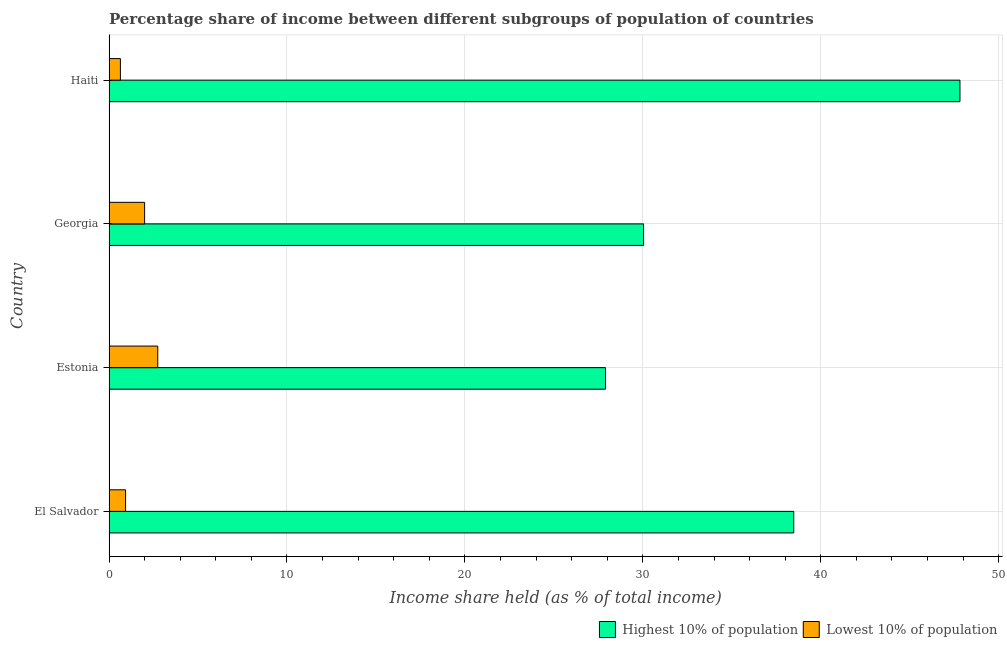How many different coloured bars are there?
Keep it short and to the point. 2. How many groups of bars are there?
Provide a succinct answer. 4. Are the number of bars per tick equal to the number of legend labels?
Provide a short and direct response. Yes. Are the number of bars on each tick of the Y-axis equal?
Offer a terse response. Yes. How many bars are there on the 3rd tick from the bottom?
Your answer should be compact. 2. What is the label of the 3rd group of bars from the top?
Keep it short and to the point. Estonia. What is the income share held by highest 10% of the population in Georgia?
Provide a short and direct response. 30.04. Across all countries, what is the maximum income share held by highest 10% of the population?
Your answer should be compact. 47.82. Across all countries, what is the minimum income share held by highest 10% of the population?
Ensure brevity in your answer.  27.9. In which country was the income share held by highest 10% of the population maximum?
Offer a terse response. Haiti. In which country was the income share held by highest 10% of the population minimum?
Give a very brief answer. Estonia. What is the total income share held by lowest 10% of the population in the graph?
Ensure brevity in your answer.  6.31. What is the difference between the income share held by highest 10% of the population in El Salvador and that in Haiti?
Offer a terse response. -9.34. What is the difference between the income share held by highest 10% of the population in Estonia and the income share held by lowest 10% of the population in Georgia?
Provide a succinct answer. 25.9. What is the average income share held by highest 10% of the population per country?
Provide a short and direct response. 36.06. What is the difference between the income share held by highest 10% of the population and income share held by lowest 10% of the population in El Salvador?
Keep it short and to the point. 37.55. In how many countries, is the income share held by highest 10% of the population greater than 44 %?
Ensure brevity in your answer.  1. What is the ratio of the income share held by highest 10% of the population in El Salvador to that in Estonia?
Make the answer very short. 1.38. Is the difference between the income share held by highest 10% of the population in Georgia and Haiti greater than the difference between the income share held by lowest 10% of the population in Georgia and Haiti?
Your answer should be compact. No. What is the difference between the highest and the second highest income share held by highest 10% of the population?
Offer a very short reply. 9.34. Is the sum of the income share held by highest 10% of the population in El Salvador and Estonia greater than the maximum income share held by lowest 10% of the population across all countries?
Provide a succinct answer. Yes. What does the 2nd bar from the top in Georgia represents?
Provide a short and direct response. Highest 10% of population. What does the 2nd bar from the bottom in Georgia represents?
Give a very brief answer. Lowest 10% of population. Does the graph contain any zero values?
Offer a terse response. No. Where does the legend appear in the graph?
Your answer should be compact. Bottom right. What is the title of the graph?
Keep it short and to the point. Percentage share of income between different subgroups of population of countries. Does "Imports" appear as one of the legend labels in the graph?
Ensure brevity in your answer.  No. What is the label or title of the X-axis?
Offer a terse response. Income share held (as % of total income). What is the Income share held (as % of total income) in Highest 10% of population in El Salvador?
Offer a very short reply. 38.48. What is the Income share held (as % of total income) of Highest 10% of population in Estonia?
Give a very brief answer. 27.9. What is the Income share held (as % of total income) in Lowest 10% of population in Estonia?
Keep it short and to the point. 2.74. What is the Income share held (as % of total income) in Highest 10% of population in Georgia?
Ensure brevity in your answer.  30.04. What is the Income share held (as % of total income) in Highest 10% of population in Haiti?
Keep it short and to the point. 47.82. What is the Income share held (as % of total income) in Lowest 10% of population in Haiti?
Your response must be concise. 0.64. Across all countries, what is the maximum Income share held (as % of total income) in Highest 10% of population?
Keep it short and to the point. 47.82. Across all countries, what is the maximum Income share held (as % of total income) in Lowest 10% of population?
Your answer should be compact. 2.74. Across all countries, what is the minimum Income share held (as % of total income) in Highest 10% of population?
Give a very brief answer. 27.9. Across all countries, what is the minimum Income share held (as % of total income) in Lowest 10% of population?
Ensure brevity in your answer.  0.64. What is the total Income share held (as % of total income) in Highest 10% of population in the graph?
Offer a very short reply. 144.24. What is the total Income share held (as % of total income) in Lowest 10% of population in the graph?
Your response must be concise. 6.31. What is the difference between the Income share held (as % of total income) of Highest 10% of population in El Salvador and that in Estonia?
Make the answer very short. 10.58. What is the difference between the Income share held (as % of total income) of Lowest 10% of population in El Salvador and that in Estonia?
Offer a very short reply. -1.81. What is the difference between the Income share held (as % of total income) in Highest 10% of population in El Salvador and that in Georgia?
Ensure brevity in your answer.  8.44. What is the difference between the Income share held (as % of total income) of Lowest 10% of population in El Salvador and that in Georgia?
Provide a short and direct response. -1.07. What is the difference between the Income share held (as % of total income) in Highest 10% of population in El Salvador and that in Haiti?
Make the answer very short. -9.34. What is the difference between the Income share held (as % of total income) of Lowest 10% of population in El Salvador and that in Haiti?
Make the answer very short. 0.29. What is the difference between the Income share held (as % of total income) of Highest 10% of population in Estonia and that in Georgia?
Give a very brief answer. -2.14. What is the difference between the Income share held (as % of total income) of Lowest 10% of population in Estonia and that in Georgia?
Your answer should be compact. 0.74. What is the difference between the Income share held (as % of total income) in Highest 10% of population in Estonia and that in Haiti?
Your answer should be very brief. -19.92. What is the difference between the Income share held (as % of total income) in Highest 10% of population in Georgia and that in Haiti?
Provide a short and direct response. -17.78. What is the difference between the Income share held (as % of total income) of Lowest 10% of population in Georgia and that in Haiti?
Make the answer very short. 1.36. What is the difference between the Income share held (as % of total income) in Highest 10% of population in El Salvador and the Income share held (as % of total income) in Lowest 10% of population in Estonia?
Your answer should be very brief. 35.74. What is the difference between the Income share held (as % of total income) in Highest 10% of population in El Salvador and the Income share held (as % of total income) in Lowest 10% of population in Georgia?
Keep it short and to the point. 36.48. What is the difference between the Income share held (as % of total income) of Highest 10% of population in El Salvador and the Income share held (as % of total income) of Lowest 10% of population in Haiti?
Offer a terse response. 37.84. What is the difference between the Income share held (as % of total income) in Highest 10% of population in Estonia and the Income share held (as % of total income) in Lowest 10% of population in Georgia?
Your response must be concise. 25.9. What is the difference between the Income share held (as % of total income) of Highest 10% of population in Estonia and the Income share held (as % of total income) of Lowest 10% of population in Haiti?
Provide a succinct answer. 27.26. What is the difference between the Income share held (as % of total income) of Highest 10% of population in Georgia and the Income share held (as % of total income) of Lowest 10% of population in Haiti?
Provide a short and direct response. 29.4. What is the average Income share held (as % of total income) in Highest 10% of population per country?
Your response must be concise. 36.06. What is the average Income share held (as % of total income) in Lowest 10% of population per country?
Your answer should be very brief. 1.58. What is the difference between the Income share held (as % of total income) of Highest 10% of population and Income share held (as % of total income) of Lowest 10% of population in El Salvador?
Your response must be concise. 37.55. What is the difference between the Income share held (as % of total income) of Highest 10% of population and Income share held (as % of total income) of Lowest 10% of population in Estonia?
Provide a short and direct response. 25.16. What is the difference between the Income share held (as % of total income) in Highest 10% of population and Income share held (as % of total income) in Lowest 10% of population in Georgia?
Your answer should be compact. 28.04. What is the difference between the Income share held (as % of total income) of Highest 10% of population and Income share held (as % of total income) of Lowest 10% of population in Haiti?
Keep it short and to the point. 47.18. What is the ratio of the Income share held (as % of total income) of Highest 10% of population in El Salvador to that in Estonia?
Make the answer very short. 1.38. What is the ratio of the Income share held (as % of total income) in Lowest 10% of population in El Salvador to that in Estonia?
Offer a terse response. 0.34. What is the ratio of the Income share held (as % of total income) in Highest 10% of population in El Salvador to that in Georgia?
Ensure brevity in your answer.  1.28. What is the ratio of the Income share held (as % of total income) of Lowest 10% of population in El Salvador to that in Georgia?
Give a very brief answer. 0.47. What is the ratio of the Income share held (as % of total income) of Highest 10% of population in El Salvador to that in Haiti?
Keep it short and to the point. 0.8. What is the ratio of the Income share held (as % of total income) of Lowest 10% of population in El Salvador to that in Haiti?
Offer a very short reply. 1.45. What is the ratio of the Income share held (as % of total income) in Highest 10% of population in Estonia to that in Georgia?
Ensure brevity in your answer.  0.93. What is the ratio of the Income share held (as % of total income) of Lowest 10% of population in Estonia to that in Georgia?
Offer a very short reply. 1.37. What is the ratio of the Income share held (as % of total income) in Highest 10% of population in Estonia to that in Haiti?
Your answer should be very brief. 0.58. What is the ratio of the Income share held (as % of total income) of Lowest 10% of population in Estonia to that in Haiti?
Keep it short and to the point. 4.28. What is the ratio of the Income share held (as % of total income) in Highest 10% of population in Georgia to that in Haiti?
Your response must be concise. 0.63. What is the ratio of the Income share held (as % of total income) of Lowest 10% of population in Georgia to that in Haiti?
Your response must be concise. 3.12. What is the difference between the highest and the second highest Income share held (as % of total income) in Highest 10% of population?
Give a very brief answer. 9.34. What is the difference between the highest and the second highest Income share held (as % of total income) in Lowest 10% of population?
Make the answer very short. 0.74. What is the difference between the highest and the lowest Income share held (as % of total income) in Highest 10% of population?
Offer a terse response. 19.92. 